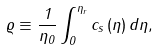<formula> <loc_0><loc_0><loc_500><loc_500>\varrho \equiv \frac { 1 } { \eta _ { 0 } } \int _ { 0 } ^ { \eta _ { r } } c _ { s } \left ( \eta \right ) d \eta ,</formula> 